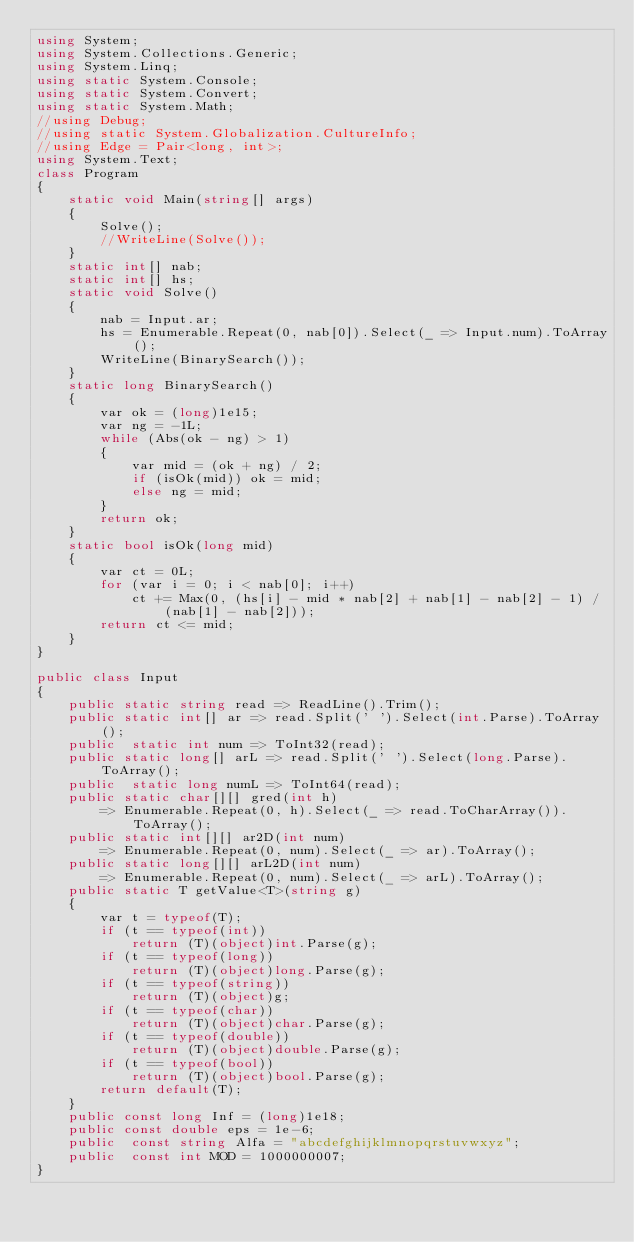<code> <loc_0><loc_0><loc_500><loc_500><_C#_>using System;
using System.Collections.Generic;
using System.Linq;
using static System.Console;
using static System.Convert;
using static System.Math;
//using Debug;
//using static System.Globalization.CultureInfo;
//using Edge = Pair<long, int>;
using System.Text;
class Program
{ 
    static void Main(string[] args)
    {
        Solve();
        //WriteLine(Solve());
    }
    static int[] nab;
    static int[] hs;
    static void Solve()
    {
        nab = Input.ar;
        hs = Enumerable.Repeat(0, nab[0]).Select(_ => Input.num).ToArray();
        WriteLine(BinarySearch());
    }
    static long BinarySearch()
    {
        var ok = (long)1e15;
        var ng = -1L;
        while (Abs(ok - ng) > 1)
        {
            var mid = (ok + ng) / 2;
            if (isOk(mid)) ok = mid;
            else ng = mid;
        }
        return ok;
    }
    static bool isOk(long mid)
    {
        var ct = 0L;
        for (var i = 0; i < nab[0]; i++)
            ct += Max(0, (hs[i] - mid * nab[2] + nab[1] - nab[2] - 1) / (nab[1] - nab[2]));
        return ct <= mid;
    }
}

public class Input
{
    public static string read => ReadLine().Trim();
    public static int[] ar => read.Split(' ').Select(int.Parse).ToArray();
    public  static int num => ToInt32(read);
    public static long[] arL => read.Split(' ').Select(long.Parse).ToArray();
    public  static long numL => ToInt64(read);
    public static char[][] gred(int h) 
        => Enumerable.Repeat(0, h).Select(_ => read.ToCharArray()).ToArray();
    public static int[][] ar2D(int num)
        => Enumerable.Repeat(0, num).Select(_ => ar).ToArray();
    public static long[][] arL2D(int num)
        => Enumerable.Repeat(0, num).Select(_ => arL).ToArray();
    public static T getValue<T>(string g)
    {
        var t = typeof(T);
        if (t == typeof(int))
            return (T)(object)int.Parse(g);
        if (t == typeof(long))
            return (T)(object)long.Parse(g);
        if (t == typeof(string))
            return (T)(object)g;
        if (t == typeof(char))
            return (T)(object)char.Parse(g);
        if (t == typeof(double))
            return (T)(object)double.Parse(g);
        if (t == typeof(bool))
            return (T)(object)bool.Parse(g);
        return default(T);
    }
    public const long Inf = (long)1e18;
    public const double eps = 1e-6;
    public  const string Alfa = "abcdefghijklmnopqrstuvwxyz";
    public  const int MOD = 1000000007;
}
</code> 